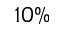Convert formula to latex. <formula><loc_0><loc_0><loc_500><loc_500>1 0 \%</formula> 